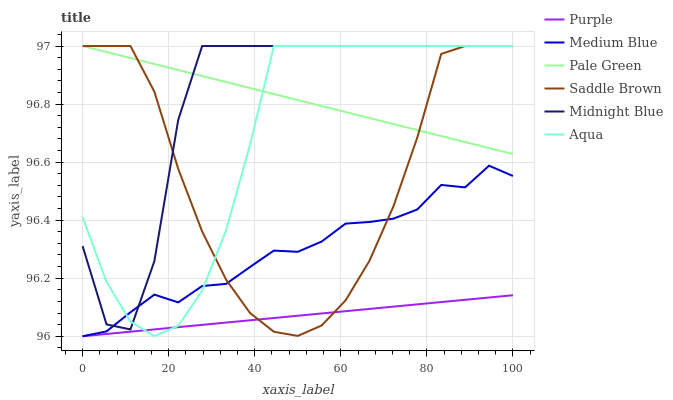Does Purple have the minimum area under the curve?
Answer yes or no. Yes. Does Midnight Blue have the maximum area under the curve?
Answer yes or no. Yes. Does Medium Blue have the minimum area under the curve?
Answer yes or no. No. Does Medium Blue have the maximum area under the curve?
Answer yes or no. No. Is Pale Green the smoothest?
Answer yes or no. Yes. Is Midnight Blue the roughest?
Answer yes or no. Yes. Is Purple the smoothest?
Answer yes or no. No. Is Purple the roughest?
Answer yes or no. No. Does Purple have the lowest value?
Answer yes or no. Yes. Does Aqua have the lowest value?
Answer yes or no. No. Does Saddle Brown have the highest value?
Answer yes or no. Yes. Does Medium Blue have the highest value?
Answer yes or no. No. Is Purple less than Pale Green?
Answer yes or no. Yes. Is Pale Green greater than Purple?
Answer yes or no. Yes. Does Pale Green intersect Saddle Brown?
Answer yes or no. Yes. Is Pale Green less than Saddle Brown?
Answer yes or no. No. Is Pale Green greater than Saddle Brown?
Answer yes or no. No. Does Purple intersect Pale Green?
Answer yes or no. No. 